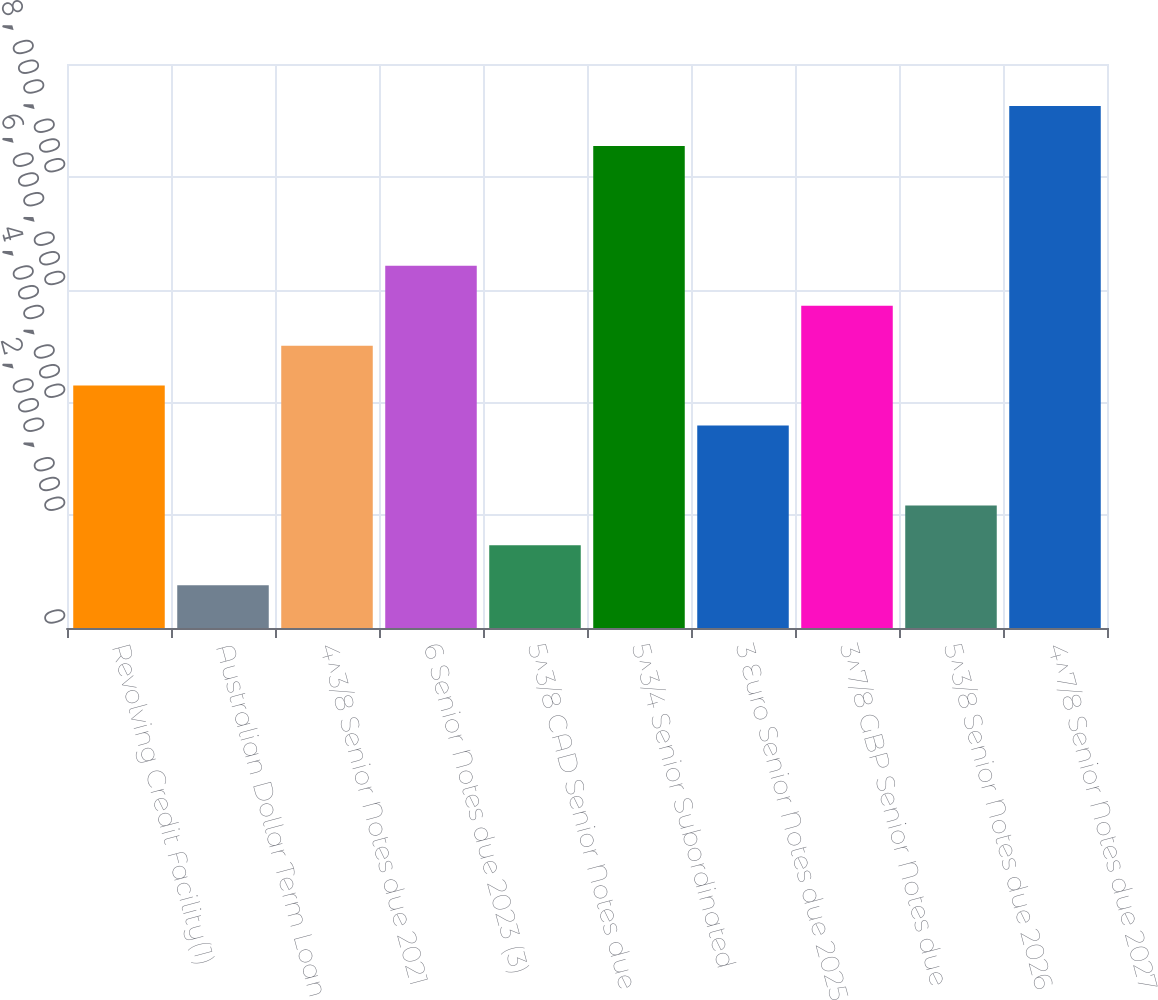<chart> <loc_0><loc_0><loc_500><loc_500><bar_chart><fcel>Revolving Credit Facility(1)<fcel>Australian Dollar Term Loan<fcel>4^3/8 Senior Notes due 2021<fcel>6 Senior Notes due 2023 (3)<fcel>5^3/8 CAD Senior Notes due<fcel>5^3/4 Senior Subordinated<fcel>3 Euro Senior Notes due 2025<fcel>3^7/8 GBP Senior Notes due<fcel>5^3/8 Senior Notes due 2026<fcel>4^7/8 Senior Notes due 2027<nl><fcel>4.29771e+06<fcel>757951<fcel>5.00566e+06<fcel>6.42156e+06<fcel>1.4659e+06<fcel>8.54541e+06<fcel>3.58976e+06<fcel>5.71361e+06<fcel>2.17385e+06<fcel>9.25336e+06<nl></chart> 